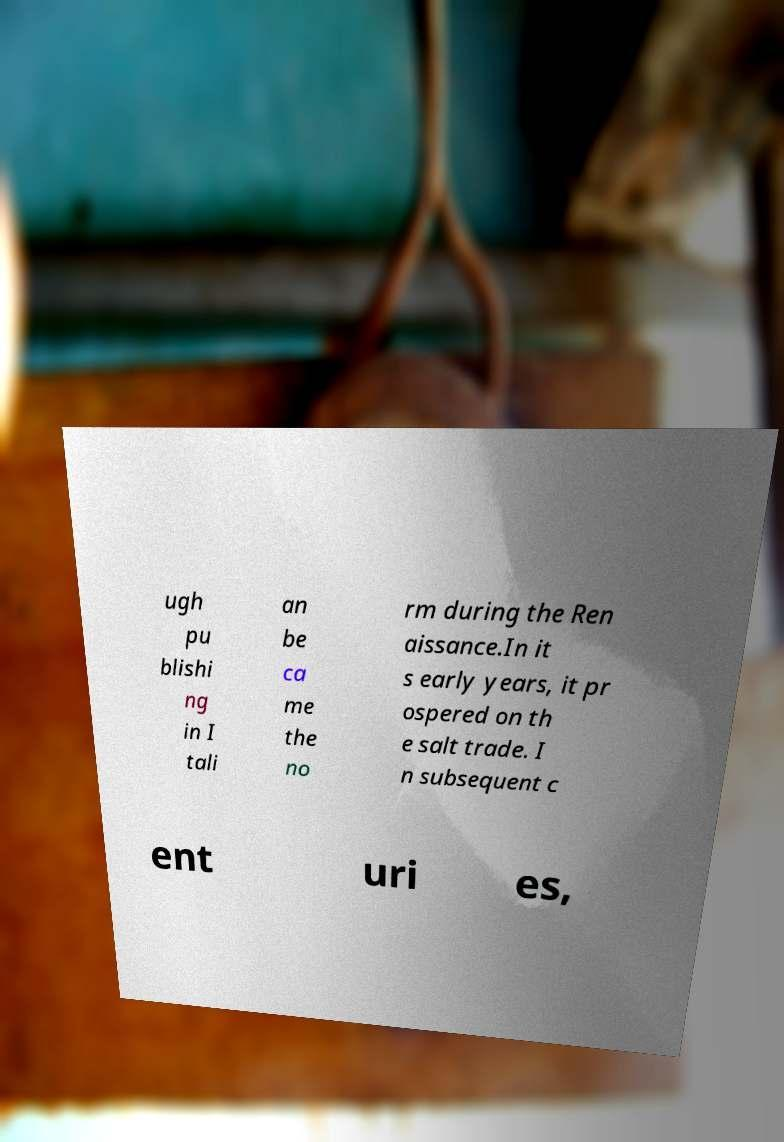Could you assist in decoding the text presented in this image and type it out clearly? ugh pu blishi ng in I tali an be ca me the no rm during the Ren aissance.In it s early years, it pr ospered on th e salt trade. I n subsequent c ent uri es, 